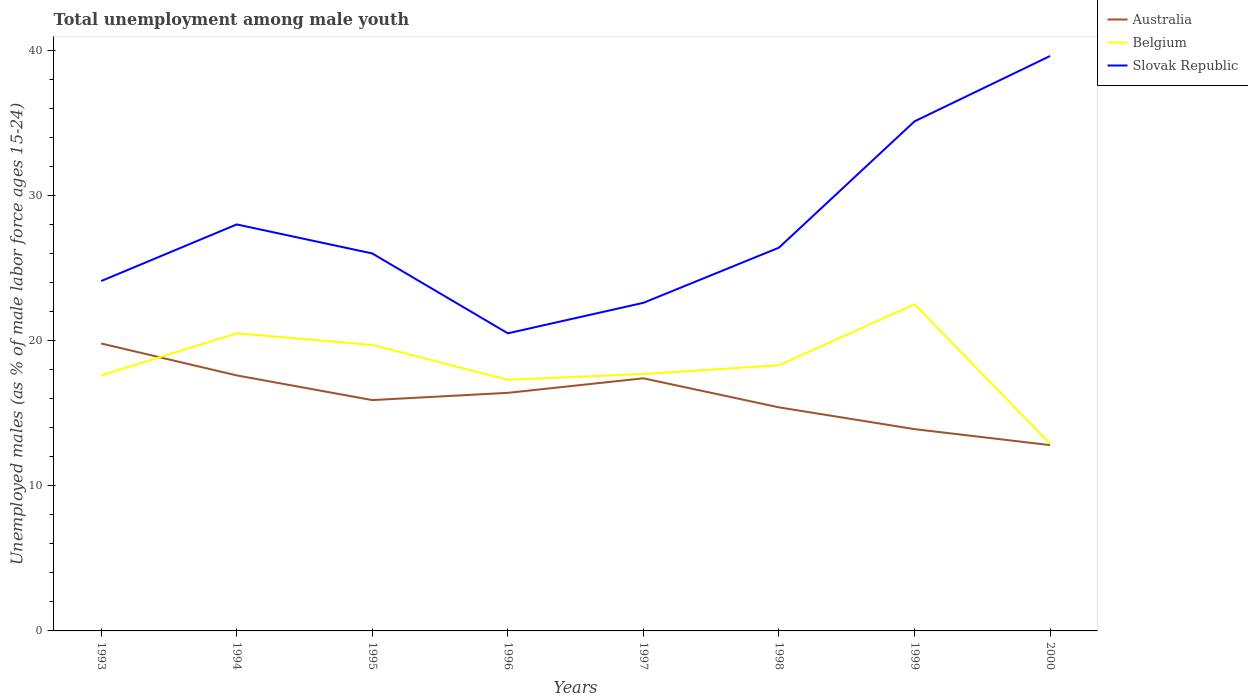Does the line corresponding to Slovak Republic intersect with the line corresponding to Belgium?
Ensure brevity in your answer.  No. What is the total percentage of unemployed males in in Australia in the graph?
Your response must be concise. 3.4. What is the difference between the highest and the second highest percentage of unemployed males in in Belgium?
Your response must be concise. 9.6. What is the difference between the highest and the lowest percentage of unemployed males in in Australia?
Make the answer very short. 4. How many lines are there?
Provide a succinct answer. 3. Are the values on the major ticks of Y-axis written in scientific E-notation?
Offer a very short reply. No. Does the graph contain any zero values?
Your answer should be very brief. No. Does the graph contain grids?
Provide a short and direct response. No. Where does the legend appear in the graph?
Provide a short and direct response. Top right. How many legend labels are there?
Keep it short and to the point. 3. What is the title of the graph?
Ensure brevity in your answer.  Total unemployment among male youth. What is the label or title of the X-axis?
Offer a terse response. Years. What is the label or title of the Y-axis?
Offer a very short reply. Unemployed males (as % of male labor force ages 15-24). What is the Unemployed males (as % of male labor force ages 15-24) of Australia in 1993?
Ensure brevity in your answer.  19.8. What is the Unemployed males (as % of male labor force ages 15-24) of Belgium in 1993?
Your response must be concise. 17.6. What is the Unemployed males (as % of male labor force ages 15-24) of Slovak Republic in 1993?
Provide a short and direct response. 24.1. What is the Unemployed males (as % of male labor force ages 15-24) of Australia in 1994?
Offer a terse response. 17.6. What is the Unemployed males (as % of male labor force ages 15-24) in Belgium in 1994?
Ensure brevity in your answer.  20.5. What is the Unemployed males (as % of male labor force ages 15-24) of Australia in 1995?
Offer a terse response. 15.9. What is the Unemployed males (as % of male labor force ages 15-24) of Belgium in 1995?
Your response must be concise. 19.7. What is the Unemployed males (as % of male labor force ages 15-24) of Australia in 1996?
Offer a terse response. 16.4. What is the Unemployed males (as % of male labor force ages 15-24) in Belgium in 1996?
Provide a succinct answer. 17.3. What is the Unemployed males (as % of male labor force ages 15-24) in Australia in 1997?
Give a very brief answer. 17.4. What is the Unemployed males (as % of male labor force ages 15-24) of Belgium in 1997?
Your response must be concise. 17.7. What is the Unemployed males (as % of male labor force ages 15-24) in Slovak Republic in 1997?
Offer a very short reply. 22.6. What is the Unemployed males (as % of male labor force ages 15-24) in Australia in 1998?
Give a very brief answer. 15.4. What is the Unemployed males (as % of male labor force ages 15-24) of Belgium in 1998?
Make the answer very short. 18.3. What is the Unemployed males (as % of male labor force ages 15-24) of Slovak Republic in 1998?
Provide a succinct answer. 26.4. What is the Unemployed males (as % of male labor force ages 15-24) in Australia in 1999?
Your answer should be very brief. 13.9. What is the Unemployed males (as % of male labor force ages 15-24) in Slovak Republic in 1999?
Give a very brief answer. 35.1. What is the Unemployed males (as % of male labor force ages 15-24) of Australia in 2000?
Keep it short and to the point. 12.8. What is the Unemployed males (as % of male labor force ages 15-24) of Belgium in 2000?
Provide a succinct answer. 12.9. What is the Unemployed males (as % of male labor force ages 15-24) in Slovak Republic in 2000?
Ensure brevity in your answer.  39.6. Across all years, what is the maximum Unemployed males (as % of male labor force ages 15-24) in Australia?
Keep it short and to the point. 19.8. Across all years, what is the maximum Unemployed males (as % of male labor force ages 15-24) in Slovak Republic?
Provide a succinct answer. 39.6. Across all years, what is the minimum Unemployed males (as % of male labor force ages 15-24) of Australia?
Your answer should be very brief. 12.8. Across all years, what is the minimum Unemployed males (as % of male labor force ages 15-24) in Belgium?
Provide a short and direct response. 12.9. Across all years, what is the minimum Unemployed males (as % of male labor force ages 15-24) in Slovak Republic?
Provide a short and direct response. 20.5. What is the total Unemployed males (as % of male labor force ages 15-24) in Australia in the graph?
Make the answer very short. 129.2. What is the total Unemployed males (as % of male labor force ages 15-24) in Belgium in the graph?
Offer a terse response. 146.5. What is the total Unemployed males (as % of male labor force ages 15-24) in Slovak Republic in the graph?
Give a very brief answer. 222.3. What is the difference between the Unemployed males (as % of male labor force ages 15-24) of Australia in 1993 and that in 1994?
Keep it short and to the point. 2.2. What is the difference between the Unemployed males (as % of male labor force ages 15-24) of Belgium in 1993 and that in 1994?
Provide a succinct answer. -2.9. What is the difference between the Unemployed males (as % of male labor force ages 15-24) in Slovak Republic in 1993 and that in 1994?
Give a very brief answer. -3.9. What is the difference between the Unemployed males (as % of male labor force ages 15-24) in Australia in 1993 and that in 1995?
Your answer should be compact. 3.9. What is the difference between the Unemployed males (as % of male labor force ages 15-24) of Belgium in 1993 and that in 1995?
Provide a succinct answer. -2.1. What is the difference between the Unemployed males (as % of male labor force ages 15-24) in Slovak Republic in 1993 and that in 1995?
Provide a short and direct response. -1.9. What is the difference between the Unemployed males (as % of male labor force ages 15-24) of Australia in 1993 and that in 1996?
Your response must be concise. 3.4. What is the difference between the Unemployed males (as % of male labor force ages 15-24) of Belgium in 1993 and that in 1997?
Provide a short and direct response. -0.1. What is the difference between the Unemployed males (as % of male labor force ages 15-24) of Slovak Republic in 1993 and that in 1997?
Give a very brief answer. 1.5. What is the difference between the Unemployed males (as % of male labor force ages 15-24) of Belgium in 1993 and that in 1998?
Your response must be concise. -0.7. What is the difference between the Unemployed males (as % of male labor force ages 15-24) in Australia in 1993 and that in 1999?
Your answer should be compact. 5.9. What is the difference between the Unemployed males (as % of male labor force ages 15-24) of Slovak Republic in 1993 and that in 2000?
Ensure brevity in your answer.  -15.5. What is the difference between the Unemployed males (as % of male labor force ages 15-24) of Australia in 1994 and that in 1996?
Make the answer very short. 1.2. What is the difference between the Unemployed males (as % of male labor force ages 15-24) of Belgium in 1994 and that in 1996?
Offer a very short reply. 3.2. What is the difference between the Unemployed males (as % of male labor force ages 15-24) in Slovak Republic in 1994 and that in 1996?
Keep it short and to the point. 7.5. What is the difference between the Unemployed males (as % of male labor force ages 15-24) in Australia in 1994 and that in 1997?
Ensure brevity in your answer.  0.2. What is the difference between the Unemployed males (as % of male labor force ages 15-24) in Slovak Republic in 1994 and that in 1997?
Give a very brief answer. 5.4. What is the difference between the Unemployed males (as % of male labor force ages 15-24) of Slovak Republic in 1994 and that in 1998?
Keep it short and to the point. 1.6. What is the difference between the Unemployed males (as % of male labor force ages 15-24) in Australia in 1994 and that in 1999?
Keep it short and to the point. 3.7. What is the difference between the Unemployed males (as % of male labor force ages 15-24) in Belgium in 1994 and that in 1999?
Provide a succinct answer. -2. What is the difference between the Unemployed males (as % of male labor force ages 15-24) of Belgium in 1994 and that in 2000?
Offer a terse response. 7.6. What is the difference between the Unemployed males (as % of male labor force ages 15-24) in Belgium in 1995 and that in 1996?
Offer a very short reply. 2.4. What is the difference between the Unemployed males (as % of male labor force ages 15-24) in Belgium in 1995 and that in 1997?
Provide a short and direct response. 2. What is the difference between the Unemployed males (as % of male labor force ages 15-24) in Slovak Republic in 1995 and that in 1997?
Your answer should be very brief. 3.4. What is the difference between the Unemployed males (as % of male labor force ages 15-24) in Slovak Republic in 1995 and that in 1999?
Provide a short and direct response. -9.1. What is the difference between the Unemployed males (as % of male labor force ages 15-24) in Australia in 1995 and that in 2000?
Offer a terse response. 3.1. What is the difference between the Unemployed males (as % of male labor force ages 15-24) in Slovak Republic in 1995 and that in 2000?
Ensure brevity in your answer.  -13.6. What is the difference between the Unemployed males (as % of male labor force ages 15-24) of Australia in 1996 and that in 1997?
Give a very brief answer. -1. What is the difference between the Unemployed males (as % of male labor force ages 15-24) of Belgium in 1996 and that in 1997?
Keep it short and to the point. -0.4. What is the difference between the Unemployed males (as % of male labor force ages 15-24) of Australia in 1996 and that in 1998?
Offer a terse response. 1. What is the difference between the Unemployed males (as % of male labor force ages 15-24) in Slovak Republic in 1996 and that in 1998?
Provide a short and direct response. -5.9. What is the difference between the Unemployed males (as % of male labor force ages 15-24) of Australia in 1996 and that in 1999?
Your answer should be compact. 2.5. What is the difference between the Unemployed males (as % of male labor force ages 15-24) in Slovak Republic in 1996 and that in 1999?
Ensure brevity in your answer.  -14.6. What is the difference between the Unemployed males (as % of male labor force ages 15-24) in Slovak Republic in 1996 and that in 2000?
Ensure brevity in your answer.  -19.1. What is the difference between the Unemployed males (as % of male labor force ages 15-24) of Slovak Republic in 1997 and that in 1998?
Make the answer very short. -3.8. What is the difference between the Unemployed males (as % of male labor force ages 15-24) of Australia in 1997 and that in 1999?
Offer a very short reply. 3.5. What is the difference between the Unemployed males (as % of male labor force ages 15-24) in Australia in 1997 and that in 2000?
Your response must be concise. 4.6. What is the difference between the Unemployed males (as % of male labor force ages 15-24) of Slovak Republic in 1997 and that in 2000?
Give a very brief answer. -17. What is the difference between the Unemployed males (as % of male labor force ages 15-24) in Slovak Republic in 1998 and that in 1999?
Ensure brevity in your answer.  -8.7. What is the difference between the Unemployed males (as % of male labor force ages 15-24) of Australia in 1999 and that in 2000?
Offer a terse response. 1.1. What is the difference between the Unemployed males (as % of male labor force ages 15-24) in Australia in 1993 and the Unemployed males (as % of male labor force ages 15-24) in Belgium in 1994?
Keep it short and to the point. -0.7. What is the difference between the Unemployed males (as % of male labor force ages 15-24) of Australia in 1993 and the Unemployed males (as % of male labor force ages 15-24) of Slovak Republic in 1995?
Ensure brevity in your answer.  -6.2. What is the difference between the Unemployed males (as % of male labor force ages 15-24) of Australia in 1993 and the Unemployed males (as % of male labor force ages 15-24) of Belgium in 1996?
Provide a succinct answer. 2.5. What is the difference between the Unemployed males (as % of male labor force ages 15-24) of Australia in 1993 and the Unemployed males (as % of male labor force ages 15-24) of Slovak Republic in 1996?
Ensure brevity in your answer.  -0.7. What is the difference between the Unemployed males (as % of male labor force ages 15-24) in Belgium in 1993 and the Unemployed males (as % of male labor force ages 15-24) in Slovak Republic in 1996?
Provide a succinct answer. -2.9. What is the difference between the Unemployed males (as % of male labor force ages 15-24) in Belgium in 1993 and the Unemployed males (as % of male labor force ages 15-24) in Slovak Republic in 1997?
Your answer should be compact. -5. What is the difference between the Unemployed males (as % of male labor force ages 15-24) in Australia in 1993 and the Unemployed males (as % of male labor force ages 15-24) in Slovak Republic in 1998?
Your response must be concise. -6.6. What is the difference between the Unemployed males (as % of male labor force ages 15-24) of Belgium in 1993 and the Unemployed males (as % of male labor force ages 15-24) of Slovak Republic in 1998?
Keep it short and to the point. -8.8. What is the difference between the Unemployed males (as % of male labor force ages 15-24) of Australia in 1993 and the Unemployed males (as % of male labor force ages 15-24) of Slovak Republic in 1999?
Offer a very short reply. -15.3. What is the difference between the Unemployed males (as % of male labor force ages 15-24) in Belgium in 1993 and the Unemployed males (as % of male labor force ages 15-24) in Slovak Republic in 1999?
Make the answer very short. -17.5. What is the difference between the Unemployed males (as % of male labor force ages 15-24) in Australia in 1993 and the Unemployed males (as % of male labor force ages 15-24) in Slovak Republic in 2000?
Your response must be concise. -19.8. What is the difference between the Unemployed males (as % of male labor force ages 15-24) of Australia in 1994 and the Unemployed males (as % of male labor force ages 15-24) of Belgium in 1995?
Make the answer very short. -2.1. What is the difference between the Unemployed males (as % of male labor force ages 15-24) of Australia in 1994 and the Unemployed males (as % of male labor force ages 15-24) of Slovak Republic in 1995?
Offer a very short reply. -8.4. What is the difference between the Unemployed males (as % of male labor force ages 15-24) in Australia in 1994 and the Unemployed males (as % of male labor force ages 15-24) in Slovak Republic in 1996?
Make the answer very short. -2.9. What is the difference between the Unemployed males (as % of male labor force ages 15-24) of Australia in 1994 and the Unemployed males (as % of male labor force ages 15-24) of Belgium in 1997?
Keep it short and to the point. -0.1. What is the difference between the Unemployed males (as % of male labor force ages 15-24) in Australia in 1994 and the Unemployed males (as % of male labor force ages 15-24) in Slovak Republic in 1997?
Give a very brief answer. -5. What is the difference between the Unemployed males (as % of male labor force ages 15-24) in Australia in 1994 and the Unemployed males (as % of male labor force ages 15-24) in Belgium in 1998?
Keep it short and to the point. -0.7. What is the difference between the Unemployed males (as % of male labor force ages 15-24) of Australia in 1994 and the Unemployed males (as % of male labor force ages 15-24) of Slovak Republic in 1998?
Keep it short and to the point. -8.8. What is the difference between the Unemployed males (as % of male labor force ages 15-24) in Belgium in 1994 and the Unemployed males (as % of male labor force ages 15-24) in Slovak Republic in 1998?
Offer a terse response. -5.9. What is the difference between the Unemployed males (as % of male labor force ages 15-24) in Australia in 1994 and the Unemployed males (as % of male labor force ages 15-24) in Slovak Republic in 1999?
Give a very brief answer. -17.5. What is the difference between the Unemployed males (as % of male labor force ages 15-24) in Belgium in 1994 and the Unemployed males (as % of male labor force ages 15-24) in Slovak Republic in 1999?
Offer a terse response. -14.6. What is the difference between the Unemployed males (as % of male labor force ages 15-24) of Australia in 1994 and the Unemployed males (as % of male labor force ages 15-24) of Belgium in 2000?
Your response must be concise. 4.7. What is the difference between the Unemployed males (as % of male labor force ages 15-24) in Australia in 1994 and the Unemployed males (as % of male labor force ages 15-24) in Slovak Republic in 2000?
Give a very brief answer. -22. What is the difference between the Unemployed males (as % of male labor force ages 15-24) of Belgium in 1994 and the Unemployed males (as % of male labor force ages 15-24) of Slovak Republic in 2000?
Give a very brief answer. -19.1. What is the difference between the Unemployed males (as % of male labor force ages 15-24) in Australia in 1995 and the Unemployed males (as % of male labor force ages 15-24) in Belgium in 1996?
Provide a short and direct response. -1.4. What is the difference between the Unemployed males (as % of male labor force ages 15-24) in Australia in 1995 and the Unemployed males (as % of male labor force ages 15-24) in Slovak Republic in 1996?
Provide a succinct answer. -4.6. What is the difference between the Unemployed males (as % of male labor force ages 15-24) in Australia in 1995 and the Unemployed males (as % of male labor force ages 15-24) in Slovak Republic in 1997?
Provide a short and direct response. -6.7. What is the difference between the Unemployed males (as % of male labor force ages 15-24) in Belgium in 1995 and the Unemployed males (as % of male labor force ages 15-24) in Slovak Republic in 1998?
Keep it short and to the point. -6.7. What is the difference between the Unemployed males (as % of male labor force ages 15-24) of Australia in 1995 and the Unemployed males (as % of male labor force ages 15-24) of Slovak Republic in 1999?
Your answer should be compact. -19.2. What is the difference between the Unemployed males (as % of male labor force ages 15-24) in Belgium in 1995 and the Unemployed males (as % of male labor force ages 15-24) in Slovak Republic in 1999?
Make the answer very short. -15.4. What is the difference between the Unemployed males (as % of male labor force ages 15-24) in Australia in 1995 and the Unemployed males (as % of male labor force ages 15-24) in Slovak Republic in 2000?
Offer a terse response. -23.7. What is the difference between the Unemployed males (as % of male labor force ages 15-24) in Belgium in 1995 and the Unemployed males (as % of male labor force ages 15-24) in Slovak Republic in 2000?
Make the answer very short. -19.9. What is the difference between the Unemployed males (as % of male labor force ages 15-24) in Australia in 1996 and the Unemployed males (as % of male labor force ages 15-24) in Belgium in 1997?
Keep it short and to the point. -1.3. What is the difference between the Unemployed males (as % of male labor force ages 15-24) in Australia in 1996 and the Unemployed males (as % of male labor force ages 15-24) in Slovak Republic in 1997?
Keep it short and to the point. -6.2. What is the difference between the Unemployed males (as % of male labor force ages 15-24) in Australia in 1996 and the Unemployed males (as % of male labor force ages 15-24) in Belgium in 1998?
Make the answer very short. -1.9. What is the difference between the Unemployed males (as % of male labor force ages 15-24) in Australia in 1996 and the Unemployed males (as % of male labor force ages 15-24) in Slovak Republic in 1999?
Give a very brief answer. -18.7. What is the difference between the Unemployed males (as % of male labor force ages 15-24) of Belgium in 1996 and the Unemployed males (as % of male labor force ages 15-24) of Slovak Republic in 1999?
Ensure brevity in your answer.  -17.8. What is the difference between the Unemployed males (as % of male labor force ages 15-24) in Australia in 1996 and the Unemployed males (as % of male labor force ages 15-24) in Belgium in 2000?
Ensure brevity in your answer.  3.5. What is the difference between the Unemployed males (as % of male labor force ages 15-24) of Australia in 1996 and the Unemployed males (as % of male labor force ages 15-24) of Slovak Republic in 2000?
Ensure brevity in your answer.  -23.2. What is the difference between the Unemployed males (as % of male labor force ages 15-24) of Belgium in 1996 and the Unemployed males (as % of male labor force ages 15-24) of Slovak Republic in 2000?
Provide a short and direct response. -22.3. What is the difference between the Unemployed males (as % of male labor force ages 15-24) of Australia in 1997 and the Unemployed males (as % of male labor force ages 15-24) of Belgium in 1998?
Your response must be concise. -0.9. What is the difference between the Unemployed males (as % of male labor force ages 15-24) of Belgium in 1997 and the Unemployed males (as % of male labor force ages 15-24) of Slovak Republic in 1998?
Make the answer very short. -8.7. What is the difference between the Unemployed males (as % of male labor force ages 15-24) in Australia in 1997 and the Unemployed males (as % of male labor force ages 15-24) in Slovak Republic in 1999?
Your answer should be compact. -17.7. What is the difference between the Unemployed males (as % of male labor force ages 15-24) of Belgium in 1997 and the Unemployed males (as % of male labor force ages 15-24) of Slovak Republic in 1999?
Provide a short and direct response. -17.4. What is the difference between the Unemployed males (as % of male labor force ages 15-24) in Australia in 1997 and the Unemployed males (as % of male labor force ages 15-24) in Belgium in 2000?
Make the answer very short. 4.5. What is the difference between the Unemployed males (as % of male labor force ages 15-24) of Australia in 1997 and the Unemployed males (as % of male labor force ages 15-24) of Slovak Republic in 2000?
Keep it short and to the point. -22.2. What is the difference between the Unemployed males (as % of male labor force ages 15-24) in Belgium in 1997 and the Unemployed males (as % of male labor force ages 15-24) in Slovak Republic in 2000?
Give a very brief answer. -21.9. What is the difference between the Unemployed males (as % of male labor force ages 15-24) of Australia in 1998 and the Unemployed males (as % of male labor force ages 15-24) of Slovak Republic in 1999?
Keep it short and to the point. -19.7. What is the difference between the Unemployed males (as % of male labor force ages 15-24) in Belgium in 1998 and the Unemployed males (as % of male labor force ages 15-24) in Slovak Republic in 1999?
Make the answer very short. -16.8. What is the difference between the Unemployed males (as % of male labor force ages 15-24) in Australia in 1998 and the Unemployed males (as % of male labor force ages 15-24) in Belgium in 2000?
Give a very brief answer. 2.5. What is the difference between the Unemployed males (as % of male labor force ages 15-24) of Australia in 1998 and the Unemployed males (as % of male labor force ages 15-24) of Slovak Republic in 2000?
Provide a short and direct response. -24.2. What is the difference between the Unemployed males (as % of male labor force ages 15-24) of Belgium in 1998 and the Unemployed males (as % of male labor force ages 15-24) of Slovak Republic in 2000?
Keep it short and to the point. -21.3. What is the difference between the Unemployed males (as % of male labor force ages 15-24) of Australia in 1999 and the Unemployed males (as % of male labor force ages 15-24) of Slovak Republic in 2000?
Your answer should be compact. -25.7. What is the difference between the Unemployed males (as % of male labor force ages 15-24) of Belgium in 1999 and the Unemployed males (as % of male labor force ages 15-24) of Slovak Republic in 2000?
Your answer should be very brief. -17.1. What is the average Unemployed males (as % of male labor force ages 15-24) in Australia per year?
Your answer should be compact. 16.15. What is the average Unemployed males (as % of male labor force ages 15-24) in Belgium per year?
Keep it short and to the point. 18.31. What is the average Unemployed males (as % of male labor force ages 15-24) of Slovak Republic per year?
Make the answer very short. 27.79. In the year 1993, what is the difference between the Unemployed males (as % of male labor force ages 15-24) of Australia and Unemployed males (as % of male labor force ages 15-24) of Belgium?
Offer a terse response. 2.2. In the year 1993, what is the difference between the Unemployed males (as % of male labor force ages 15-24) of Australia and Unemployed males (as % of male labor force ages 15-24) of Slovak Republic?
Your answer should be very brief. -4.3. In the year 1994, what is the difference between the Unemployed males (as % of male labor force ages 15-24) of Australia and Unemployed males (as % of male labor force ages 15-24) of Slovak Republic?
Your answer should be very brief. -10.4. In the year 1994, what is the difference between the Unemployed males (as % of male labor force ages 15-24) of Belgium and Unemployed males (as % of male labor force ages 15-24) of Slovak Republic?
Provide a succinct answer. -7.5. In the year 1995, what is the difference between the Unemployed males (as % of male labor force ages 15-24) of Australia and Unemployed males (as % of male labor force ages 15-24) of Belgium?
Ensure brevity in your answer.  -3.8. In the year 1995, what is the difference between the Unemployed males (as % of male labor force ages 15-24) in Australia and Unemployed males (as % of male labor force ages 15-24) in Slovak Republic?
Your answer should be very brief. -10.1. In the year 1995, what is the difference between the Unemployed males (as % of male labor force ages 15-24) of Belgium and Unemployed males (as % of male labor force ages 15-24) of Slovak Republic?
Provide a short and direct response. -6.3. In the year 1996, what is the difference between the Unemployed males (as % of male labor force ages 15-24) in Australia and Unemployed males (as % of male labor force ages 15-24) in Slovak Republic?
Make the answer very short. -4.1. In the year 1996, what is the difference between the Unemployed males (as % of male labor force ages 15-24) of Belgium and Unemployed males (as % of male labor force ages 15-24) of Slovak Republic?
Provide a short and direct response. -3.2. In the year 1997, what is the difference between the Unemployed males (as % of male labor force ages 15-24) of Belgium and Unemployed males (as % of male labor force ages 15-24) of Slovak Republic?
Your answer should be very brief. -4.9. In the year 1998, what is the difference between the Unemployed males (as % of male labor force ages 15-24) in Australia and Unemployed males (as % of male labor force ages 15-24) in Belgium?
Keep it short and to the point. -2.9. In the year 1999, what is the difference between the Unemployed males (as % of male labor force ages 15-24) in Australia and Unemployed males (as % of male labor force ages 15-24) in Belgium?
Your response must be concise. -8.6. In the year 1999, what is the difference between the Unemployed males (as % of male labor force ages 15-24) of Australia and Unemployed males (as % of male labor force ages 15-24) of Slovak Republic?
Ensure brevity in your answer.  -21.2. In the year 2000, what is the difference between the Unemployed males (as % of male labor force ages 15-24) of Australia and Unemployed males (as % of male labor force ages 15-24) of Belgium?
Make the answer very short. -0.1. In the year 2000, what is the difference between the Unemployed males (as % of male labor force ages 15-24) in Australia and Unemployed males (as % of male labor force ages 15-24) in Slovak Republic?
Ensure brevity in your answer.  -26.8. In the year 2000, what is the difference between the Unemployed males (as % of male labor force ages 15-24) in Belgium and Unemployed males (as % of male labor force ages 15-24) in Slovak Republic?
Your answer should be very brief. -26.7. What is the ratio of the Unemployed males (as % of male labor force ages 15-24) in Australia in 1993 to that in 1994?
Keep it short and to the point. 1.12. What is the ratio of the Unemployed males (as % of male labor force ages 15-24) in Belgium in 1993 to that in 1994?
Ensure brevity in your answer.  0.86. What is the ratio of the Unemployed males (as % of male labor force ages 15-24) of Slovak Republic in 1993 to that in 1994?
Give a very brief answer. 0.86. What is the ratio of the Unemployed males (as % of male labor force ages 15-24) in Australia in 1993 to that in 1995?
Your answer should be very brief. 1.25. What is the ratio of the Unemployed males (as % of male labor force ages 15-24) of Belgium in 1993 to that in 1995?
Offer a terse response. 0.89. What is the ratio of the Unemployed males (as % of male labor force ages 15-24) of Slovak Republic in 1993 to that in 1995?
Keep it short and to the point. 0.93. What is the ratio of the Unemployed males (as % of male labor force ages 15-24) in Australia in 1993 to that in 1996?
Provide a succinct answer. 1.21. What is the ratio of the Unemployed males (as % of male labor force ages 15-24) in Belgium in 1993 to that in 1996?
Your answer should be compact. 1.02. What is the ratio of the Unemployed males (as % of male labor force ages 15-24) in Slovak Republic in 1993 to that in 1996?
Your answer should be compact. 1.18. What is the ratio of the Unemployed males (as % of male labor force ages 15-24) of Australia in 1993 to that in 1997?
Your response must be concise. 1.14. What is the ratio of the Unemployed males (as % of male labor force ages 15-24) in Slovak Republic in 1993 to that in 1997?
Provide a succinct answer. 1.07. What is the ratio of the Unemployed males (as % of male labor force ages 15-24) in Belgium in 1993 to that in 1998?
Ensure brevity in your answer.  0.96. What is the ratio of the Unemployed males (as % of male labor force ages 15-24) in Slovak Republic in 1993 to that in 1998?
Keep it short and to the point. 0.91. What is the ratio of the Unemployed males (as % of male labor force ages 15-24) of Australia in 1993 to that in 1999?
Keep it short and to the point. 1.42. What is the ratio of the Unemployed males (as % of male labor force ages 15-24) in Belgium in 1993 to that in 1999?
Offer a terse response. 0.78. What is the ratio of the Unemployed males (as % of male labor force ages 15-24) in Slovak Republic in 1993 to that in 1999?
Give a very brief answer. 0.69. What is the ratio of the Unemployed males (as % of male labor force ages 15-24) in Australia in 1993 to that in 2000?
Provide a short and direct response. 1.55. What is the ratio of the Unemployed males (as % of male labor force ages 15-24) in Belgium in 1993 to that in 2000?
Ensure brevity in your answer.  1.36. What is the ratio of the Unemployed males (as % of male labor force ages 15-24) of Slovak Republic in 1993 to that in 2000?
Offer a very short reply. 0.61. What is the ratio of the Unemployed males (as % of male labor force ages 15-24) of Australia in 1994 to that in 1995?
Keep it short and to the point. 1.11. What is the ratio of the Unemployed males (as % of male labor force ages 15-24) in Belgium in 1994 to that in 1995?
Offer a terse response. 1.04. What is the ratio of the Unemployed males (as % of male labor force ages 15-24) of Slovak Republic in 1994 to that in 1995?
Keep it short and to the point. 1.08. What is the ratio of the Unemployed males (as % of male labor force ages 15-24) of Australia in 1994 to that in 1996?
Keep it short and to the point. 1.07. What is the ratio of the Unemployed males (as % of male labor force ages 15-24) in Belgium in 1994 to that in 1996?
Your answer should be very brief. 1.19. What is the ratio of the Unemployed males (as % of male labor force ages 15-24) of Slovak Republic in 1994 to that in 1996?
Ensure brevity in your answer.  1.37. What is the ratio of the Unemployed males (as % of male labor force ages 15-24) of Australia in 1994 to that in 1997?
Provide a succinct answer. 1.01. What is the ratio of the Unemployed males (as % of male labor force ages 15-24) in Belgium in 1994 to that in 1997?
Provide a succinct answer. 1.16. What is the ratio of the Unemployed males (as % of male labor force ages 15-24) in Slovak Republic in 1994 to that in 1997?
Provide a succinct answer. 1.24. What is the ratio of the Unemployed males (as % of male labor force ages 15-24) of Belgium in 1994 to that in 1998?
Make the answer very short. 1.12. What is the ratio of the Unemployed males (as % of male labor force ages 15-24) in Slovak Republic in 1994 to that in 1998?
Your answer should be compact. 1.06. What is the ratio of the Unemployed males (as % of male labor force ages 15-24) of Australia in 1994 to that in 1999?
Your answer should be very brief. 1.27. What is the ratio of the Unemployed males (as % of male labor force ages 15-24) of Belgium in 1994 to that in 1999?
Your response must be concise. 0.91. What is the ratio of the Unemployed males (as % of male labor force ages 15-24) of Slovak Republic in 1994 to that in 1999?
Give a very brief answer. 0.8. What is the ratio of the Unemployed males (as % of male labor force ages 15-24) in Australia in 1994 to that in 2000?
Provide a short and direct response. 1.38. What is the ratio of the Unemployed males (as % of male labor force ages 15-24) of Belgium in 1994 to that in 2000?
Ensure brevity in your answer.  1.59. What is the ratio of the Unemployed males (as % of male labor force ages 15-24) in Slovak Republic in 1994 to that in 2000?
Offer a very short reply. 0.71. What is the ratio of the Unemployed males (as % of male labor force ages 15-24) in Australia in 1995 to that in 1996?
Keep it short and to the point. 0.97. What is the ratio of the Unemployed males (as % of male labor force ages 15-24) in Belgium in 1995 to that in 1996?
Offer a very short reply. 1.14. What is the ratio of the Unemployed males (as % of male labor force ages 15-24) of Slovak Republic in 1995 to that in 1996?
Your response must be concise. 1.27. What is the ratio of the Unemployed males (as % of male labor force ages 15-24) in Australia in 1995 to that in 1997?
Offer a very short reply. 0.91. What is the ratio of the Unemployed males (as % of male labor force ages 15-24) of Belgium in 1995 to that in 1997?
Make the answer very short. 1.11. What is the ratio of the Unemployed males (as % of male labor force ages 15-24) of Slovak Republic in 1995 to that in 1997?
Keep it short and to the point. 1.15. What is the ratio of the Unemployed males (as % of male labor force ages 15-24) in Australia in 1995 to that in 1998?
Give a very brief answer. 1.03. What is the ratio of the Unemployed males (as % of male labor force ages 15-24) of Belgium in 1995 to that in 1998?
Provide a short and direct response. 1.08. What is the ratio of the Unemployed males (as % of male labor force ages 15-24) in Australia in 1995 to that in 1999?
Your response must be concise. 1.14. What is the ratio of the Unemployed males (as % of male labor force ages 15-24) of Belgium in 1995 to that in 1999?
Ensure brevity in your answer.  0.88. What is the ratio of the Unemployed males (as % of male labor force ages 15-24) in Slovak Republic in 1995 to that in 1999?
Your answer should be compact. 0.74. What is the ratio of the Unemployed males (as % of male labor force ages 15-24) in Australia in 1995 to that in 2000?
Keep it short and to the point. 1.24. What is the ratio of the Unemployed males (as % of male labor force ages 15-24) in Belgium in 1995 to that in 2000?
Keep it short and to the point. 1.53. What is the ratio of the Unemployed males (as % of male labor force ages 15-24) in Slovak Republic in 1995 to that in 2000?
Offer a very short reply. 0.66. What is the ratio of the Unemployed males (as % of male labor force ages 15-24) of Australia in 1996 to that in 1997?
Offer a very short reply. 0.94. What is the ratio of the Unemployed males (as % of male labor force ages 15-24) in Belgium in 1996 to that in 1997?
Ensure brevity in your answer.  0.98. What is the ratio of the Unemployed males (as % of male labor force ages 15-24) of Slovak Republic in 1996 to that in 1997?
Make the answer very short. 0.91. What is the ratio of the Unemployed males (as % of male labor force ages 15-24) of Australia in 1996 to that in 1998?
Give a very brief answer. 1.06. What is the ratio of the Unemployed males (as % of male labor force ages 15-24) in Belgium in 1996 to that in 1998?
Offer a very short reply. 0.95. What is the ratio of the Unemployed males (as % of male labor force ages 15-24) of Slovak Republic in 1996 to that in 1998?
Your answer should be compact. 0.78. What is the ratio of the Unemployed males (as % of male labor force ages 15-24) of Australia in 1996 to that in 1999?
Ensure brevity in your answer.  1.18. What is the ratio of the Unemployed males (as % of male labor force ages 15-24) in Belgium in 1996 to that in 1999?
Your response must be concise. 0.77. What is the ratio of the Unemployed males (as % of male labor force ages 15-24) of Slovak Republic in 1996 to that in 1999?
Your answer should be very brief. 0.58. What is the ratio of the Unemployed males (as % of male labor force ages 15-24) of Australia in 1996 to that in 2000?
Keep it short and to the point. 1.28. What is the ratio of the Unemployed males (as % of male labor force ages 15-24) in Belgium in 1996 to that in 2000?
Your answer should be very brief. 1.34. What is the ratio of the Unemployed males (as % of male labor force ages 15-24) in Slovak Republic in 1996 to that in 2000?
Make the answer very short. 0.52. What is the ratio of the Unemployed males (as % of male labor force ages 15-24) of Australia in 1997 to that in 1998?
Provide a short and direct response. 1.13. What is the ratio of the Unemployed males (as % of male labor force ages 15-24) in Belgium in 1997 to that in 1998?
Your answer should be compact. 0.97. What is the ratio of the Unemployed males (as % of male labor force ages 15-24) of Slovak Republic in 1997 to that in 1998?
Your answer should be very brief. 0.86. What is the ratio of the Unemployed males (as % of male labor force ages 15-24) of Australia in 1997 to that in 1999?
Your response must be concise. 1.25. What is the ratio of the Unemployed males (as % of male labor force ages 15-24) in Belgium in 1997 to that in 1999?
Give a very brief answer. 0.79. What is the ratio of the Unemployed males (as % of male labor force ages 15-24) in Slovak Republic in 1997 to that in 1999?
Give a very brief answer. 0.64. What is the ratio of the Unemployed males (as % of male labor force ages 15-24) of Australia in 1997 to that in 2000?
Offer a terse response. 1.36. What is the ratio of the Unemployed males (as % of male labor force ages 15-24) of Belgium in 1997 to that in 2000?
Your answer should be very brief. 1.37. What is the ratio of the Unemployed males (as % of male labor force ages 15-24) in Slovak Republic in 1997 to that in 2000?
Your answer should be compact. 0.57. What is the ratio of the Unemployed males (as % of male labor force ages 15-24) of Australia in 1998 to that in 1999?
Your answer should be compact. 1.11. What is the ratio of the Unemployed males (as % of male labor force ages 15-24) in Belgium in 1998 to that in 1999?
Your answer should be compact. 0.81. What is the ratio of the Unemployed males (as % of male labor force ages 15-24) in Slovak Republic in 1998 to that in 1999?
Your response must be concise. 0.75. What is the ratio of the Unemployed males (as % of male labor force ages 15-24) in Australia in 1998 to that in 2000?
Provide a succinct answer. 1.2. What is the ratio of the Unemployed males (as % of male labor force ages 15-24) of Belgium in 1998 to that in 2000?
Provide a short and direct response. 1.42. What is the ratio of the Unemployed males (as % of male labor force ages 15-24) in Slovak Republic in 1998 to that in 2000?
Ensure brevity in your answer.  0.67. What is the ratio of the Unemployed males (as % of male labor force ages 15-24) of Australia in 1999 to that in 2000?
Your answer should be very brief. 1.09. What is the ratio of the Unemployed males (as % of male labor force ages 15-24) of Belgium in 1999 to that in 2000?
Make the answer very short. 1.74. What is the ratio of the Unemployed males (as % of male labor force ages 15-24) of Slovak Republic in 1999 to that in 2000?
Your answer should be very brief. 0.89. What is the difference between the highest and the lowest Unemployed males (as % of male labor force ages 15-24) of Slovak Republic?
Your response must be concise. 19.1. 